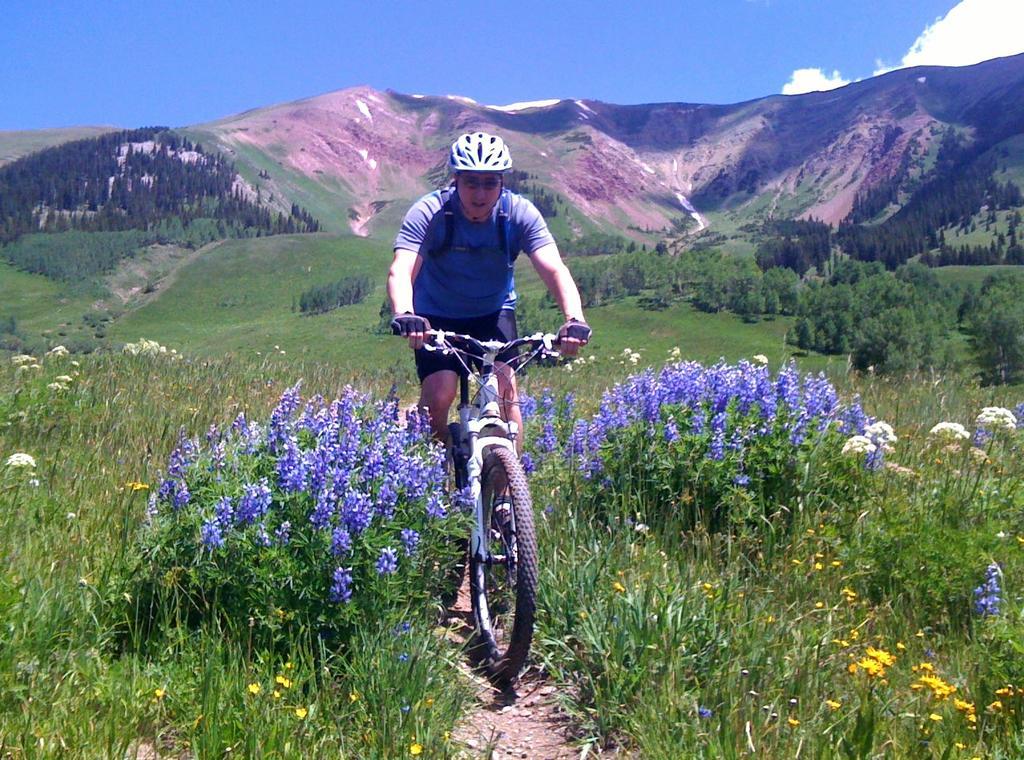Describe this image in one or two sentences. In the center of the image there is a person on the cycle. On the right and left side of the image we can see flowers, grass and plants. In the background we can see trees, grass, hills, sky and clouds. 